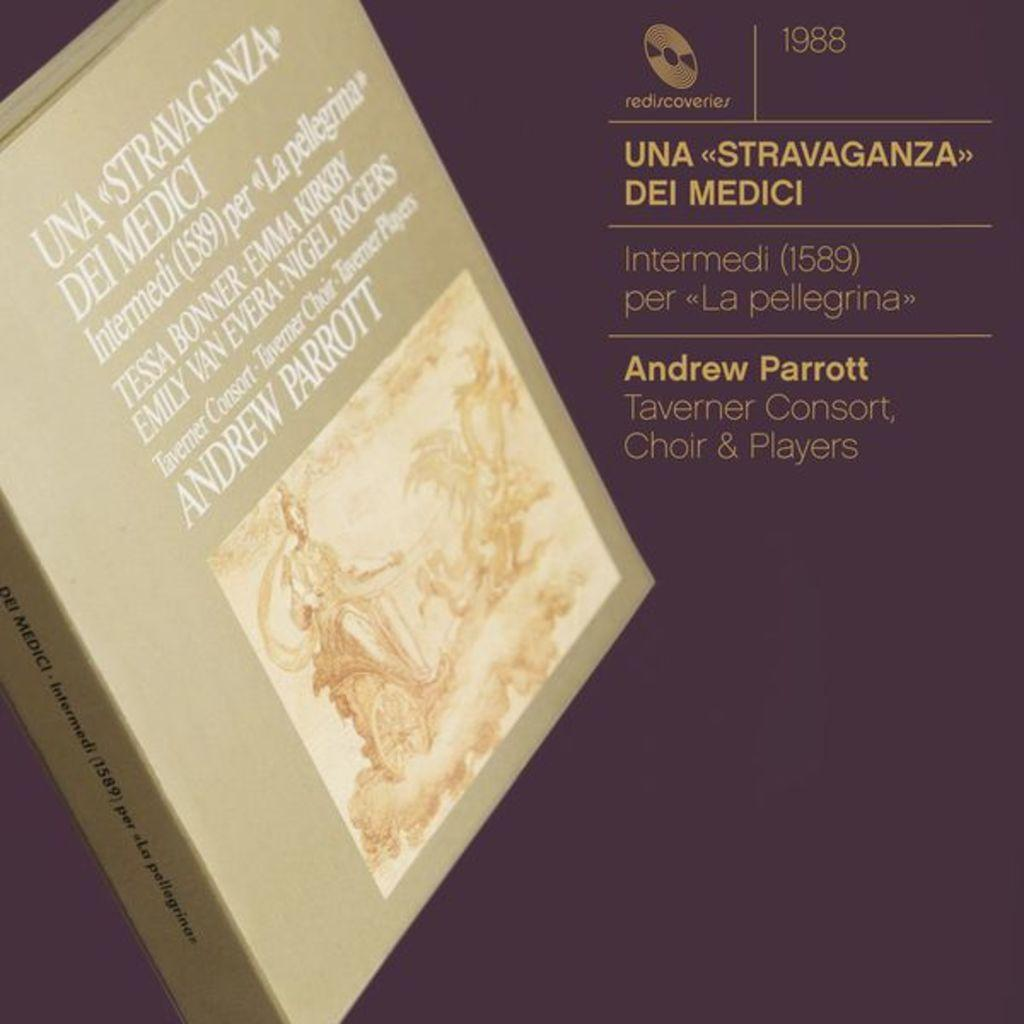<image>
Provide a brief description of the given image. A display of a box of Choir music from 1988 with description. 